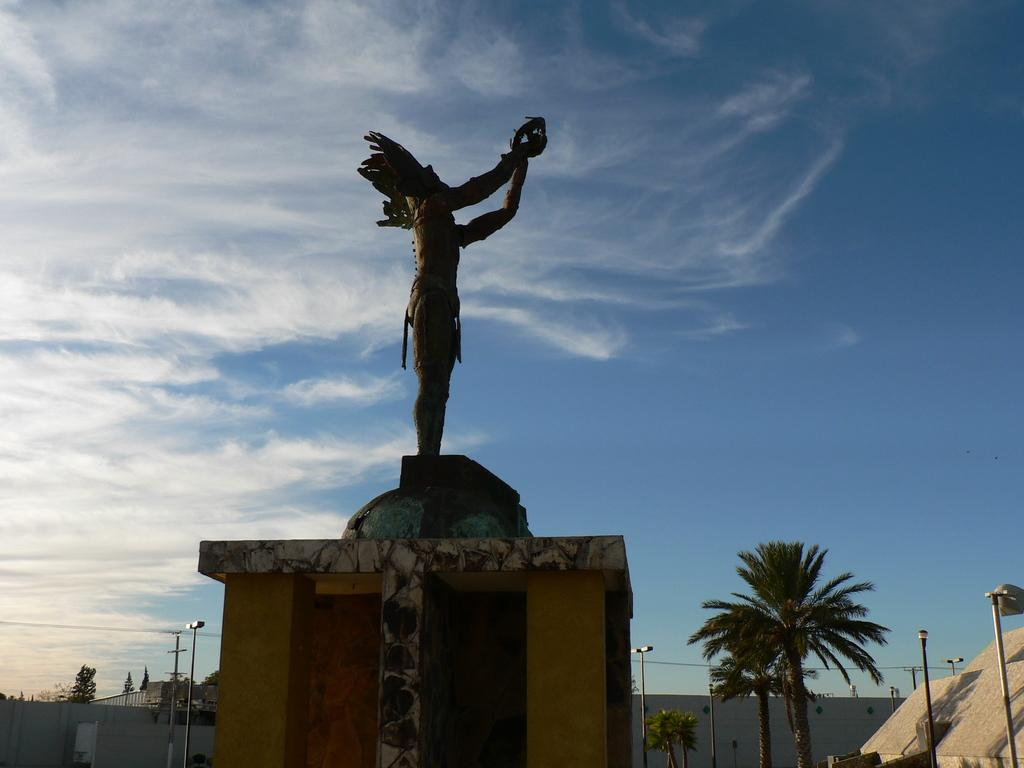What is the main subject in the image? There is a statue in the image. What other elements can be seen in the image? There are trees, light-poles, and a wall visible in the image. What is the color of the sky in the image? The sky is white and blue in color. Can you see a farmer milking a butter-producing rat in the image? No, there is no farmer, butter, or rat present in the image. 